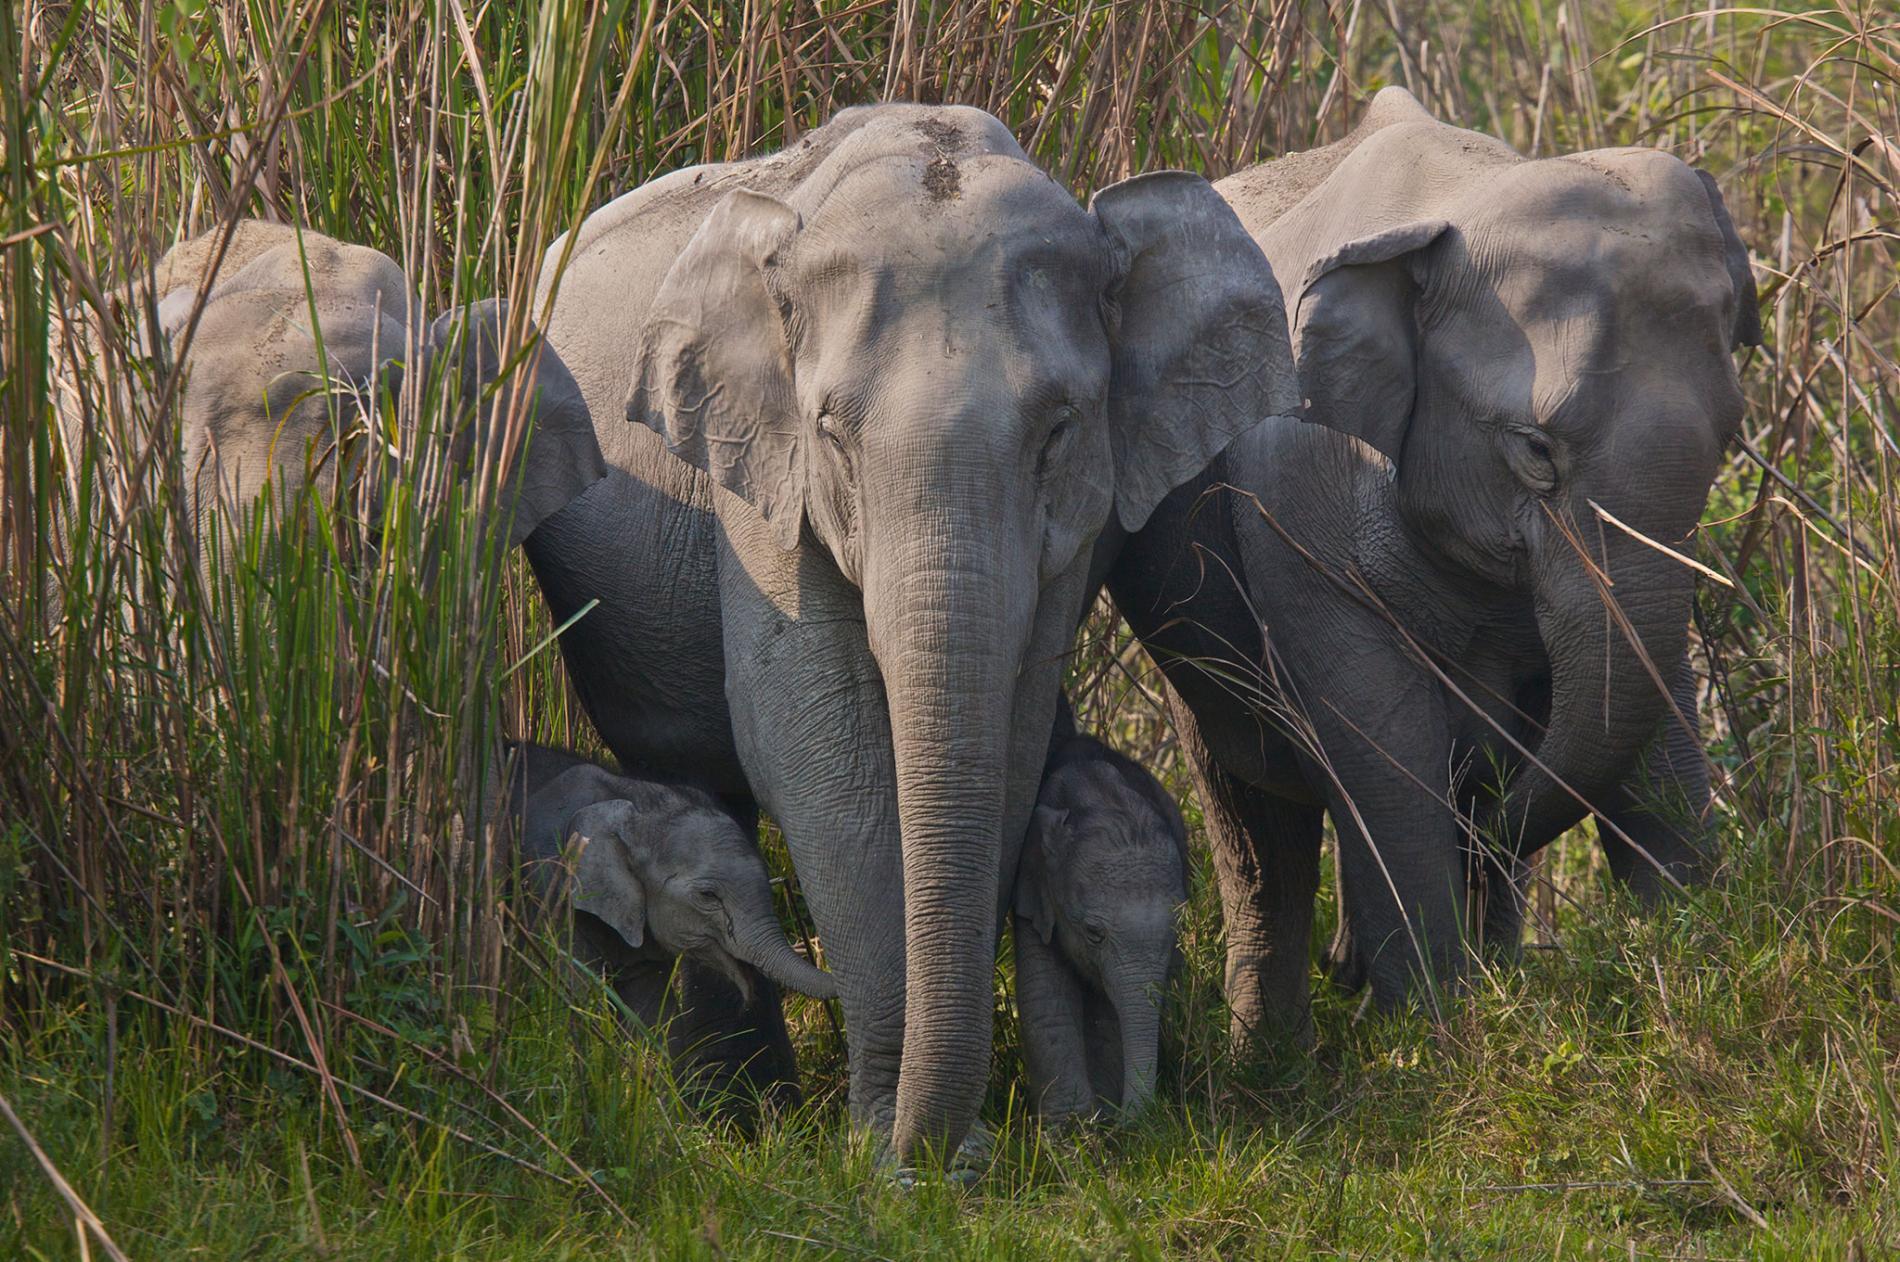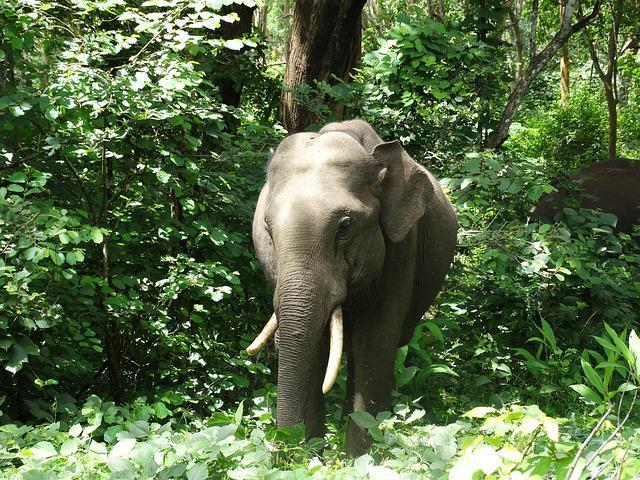The first image is the image on the left, the second image is the image on the right. Examine the images to the left and right. Is the description "At least one image is exactly one baby elephant standing between two adults." accurate? Answer yes or no. No. 